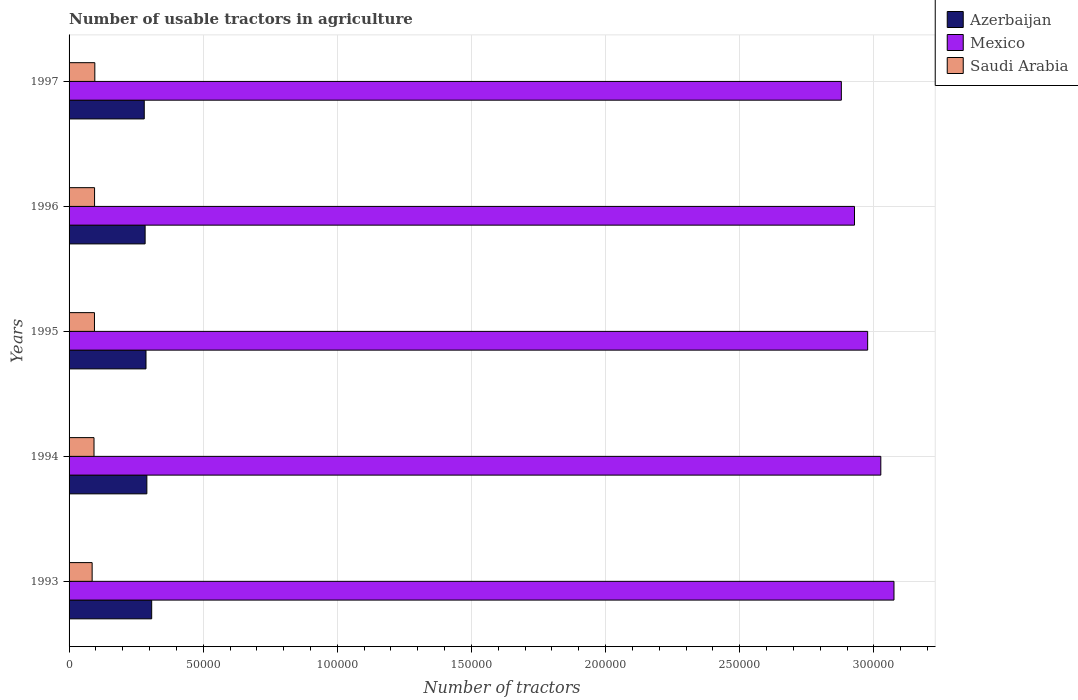How many groups of bars are there?
Give a very brief answer. 5. Are the number of bars on each tick of the Y-axis equal?
Offer a terse response. Yes. How many bars are there on the 4th tick from the bottom?
Keep it short and to the point. 3. What is the label of the 5th group of bars from the top?
Offer a terse response. 1993. What is the number of usable tractors in agriculture in Azerbaijan in 1997?
Your answer should be compact. 2.80e+04. Across all years, what is the maximum number of usable tractors in agriculture in Azerbaijan?
Your answer should be very brief. 3.08e+04. Across all years, what is the minimum number of usable tractors in agriculture in Saudi Arabia?
Offer a terse response. 8600. In which year was the number of usable tractors in agriculture in Mexico maximum?
Your response must be concise. 1993. In which year was the number of usable tractors in agriculture in Mexico minimum?
Your response must be concise. 1997. What is the total number of usable tractors in agriculture in Mexico in the graph?
Your response must be concise. 1.49e+06. What is the difference between the number of usable tractors in agriculture in Saudi Arabia in 1995 and that in 1996?
Your answer should be very brief. -31. What is the difference between the number of usable tractors in agriculture in Mexico in 1996 and the number of usable tractors in agriculture in Saudi Arabia in 1995?
Offer a very short reply. 2.83e+05. What is the average number of usable tractors in agriculture in Mexico per year?
Your answer should be very brief. 2.98e+05. In the year 1997, what is the difference between the number of usable tractors in agriculture in Saudi Arabia and number of usable tractors in agriculture in Azerbaijan?
Make the answer very short. -1.84e+04. In how many years, is the number of usable tractors in agriculture in Mexico greater than 160000 ?
Your answer should be compact. 5. What is the ratio of the number of usable tractors in agriculture in Azerbaijan in 1994 to that in 1996?
Ensure brevity in your answer.  1.02. Is the difference between the number of usable tractors in agriculture in Saudi Arabia in 1994 and 1996 greater than the difference between the number of usable tractors in agriculture in Azerbaijan in 1994 and 1996?
Offer a terse response. No. What is the difference between the highest and the lowest number of usable tractors in agriculture in Mexico?
Your answer should be very brief. 1.96e+04. Is the sum of the number of usable tractors in agriculture in Mexico in 1994 and 1997 greater than the maximum number of usable tractors in agriculture in Saudi Arabia across all years?
Offer a very short reply. Yes. What does the 1st bar from the top in 1996 represents?
Give a very brief answer. Saudi Arabia. What does the 1st bar from the bottom in 1997 represents?
Give a very brief answer. Azerbaijan. How many bars are there?
Offer a terse response. 15. Are all the bars in the graph horizontal?
Make the answer very short. Yes. How many years are there in the graph?
Keep it short and to the point. 5. Are the values on the major ticks of X-axis written in scientific E-notation?
Give a very brief answer. No. Does the graph contain grids?
Your response must be concise. Yes. Where does the legend appear in the graph?
Offer a very short reply. Top right. How many legend labels are there?
Offer a very short reply. 3. How are the legend labels stacked?
Provide a succinct answer. Vertical. What is the title of the graph?
Keep it short and to the point. Number of usable tractors in agriculture. What is the label or title of the X-axis?
Your answer should be compact. Number of tractors. What is the Number of tractors of Azerbaijan in 1993?
Provide a short and direct response. 3.08e+04. What is the Number of tractors of Mexico in 1993?
Keep it short and to the point. 3.08e+05. What is the Number of tractors of Saudi Arabia in 1993?
Your answer should be very brief. 8600. What is the Number of tractors in Azerbaijan in 1994?
Give a very brief answer. 2.90e+04. What is the Number of tractors of Mexico in 1994?
Your answer should be compact. 3.03e+05. What is the Number of tractors in Saudi Arabia in 1994?
Offer a terse response. 9300. What is the Number of tractors in Azerbaijan in 1995?
Offer a terse response. 2.87e+04. What is the Number of tractors of Mexico in 1995?
Provide a succinct answer. 2.98e+05. What is the Number of tractors in Saudi Arabia in 1995?
Provide a short and direct response. 9469. What is the Number of tractors of Azerbaijan in 1996?
Make the answer very short. 2.84e+04. What is the Number of tractors in Mexico in 1996?
Offer a terse response. 2.93e+05. What is the Number of tractors of Saudi Arabia in 1996?
Keep it short and to the point. 9500. What is the Number of tractors of Azerbaijan in 1997?
Provide a short and direct response. 2.80e+04. What is the Number of tractors of Mexico in 1997?
Make the answer very short. 2.88e+05. What is the Number of tractors in Saudi Arabia in 1997?
Provide a short and direct response. 9600. Across all years, what is the maximum Number of tractors of Azerbaijan?
Your answer should be compact. 3.08e+04. Across all years, what is the maximum Number of tractors in Mexico?
Provide a short and direct response. 3.08e+05. Across all years, what is the maximum Number of tractors of Saudi Arabia?
Your answer should be compact. 9600. Across all years, what is the minimum Number of tractors in Azerbaijan?
Ensure brevity in your answer.  2.80e+04. Across all years, what is the minimum Number of tractors of Mexico?
Make the answer very short. 2.88e+05. Across all years, what is the minimum Number of tractors in Saudi Arabia?
Give a very brief answer. 8600. What is the total Number of tractors of Azerbaijan in the graph?
Ensure brevity in your answer.  1.45e+05. What is the total Number of tractors of Mexico in the graph?
Provide a short and direct response. 1.49e+06. What is the total Number of tractors of Saudi Arabia in the graph?
Provide a short and direct response. 4.65e+04. What is the difference between the Number of tractors of Azerbaijan in 1993 and that in 1994?
Offer a terse response. 1800. What is the difference between the Number of tractors of Mexico in 1993 and that in 1994?
Keep it short and to the point. 4906. What is the difference between the Number of tractors in Saudi Arabia in 1993 and that in 1994?
Your answer should be very brief. -700. What is the difference between the Number of tractors in Azerbaijan in 1993 and that in 1995?
Offer a very short reply. 2125. What is the difference between the Number of tractors in Mexico in 1993 and that in 1995?
Provide a succinct answer. 9811. What is the difference between the Number of tractors in Saudi Arabia in 1993 and that in 1995?
Your answer should be very brief. -869. What is the difference between the Number of tractors of Azerbaijan in 1993 and that in 1996?
Your answer should be compact. 2449. What is the difference between the Number of tractors of Mexico in 1993 and that in 1996?
Provide a succinct answer. 1.47e+04. What is the difference between the Number of tractors of Saudi Arabia in 1993 and that in 1996?
Offer a terse response. -900. What is the difference between the Number of tractors of Azerbaijan in 1993 and that in 1997?
Offer a terse response. 2774. What is the difference between the Number of tractors in Mexico in 1993 and that in 1997?
Make the answer very short. 1.96e+04. What is the difference between the Number of tractors in Saudi Arabia in 1993 and that in 1997?
Provide a short and direct response. -1000. What is the difference between the Number of tractors in Azerbaijan in 1994 and that in 1995?
Provide a short and direct response. 325. What is the difference between the Number of tractors in Mexico in 1994 and that in 1995?
Your answer should be compact. 4905. What is the difference between the Number of tractors of Saudi Arabia in 1994 and that in 1995?
Keep it short and to the point. -169. What is the difference between the Number of tractors in Azerbaijan in 1994 and that in 1996?
Keep it short and to the point. 649. What is the difference between the Number of tractors of Mexico in 1994 and that in 1996?
Offer a very short reply. 9810. What is the difference between the Number of tractors of Saudi Arabia in 1994 and that in 1996?
Your answer should be compact. -200. What is the difference between the Number of tractors in Azerbaijan in 1994 and that in 1997?
Make the answer very short. 974. What is the difference between the Number of tractors of Mexico in 1994 and that in 1997?
Offer a very short reply. 1.47e+04. What is the difference between the Number of tractors of Saudi Arabia in 1994 and that in 1997?
Ensure brevity in your answer.  -300. What is the difference between the Number of tractors of Azerbaijan in 1995 and that in 1996?
Your response must be concise. 324. What is the difference between the Number of tractors in Mexico in 1995 and that in 1996?
Offer a terse response. 4905. What is the difference between the Number of tractors in Saudi Arabia in 1995 and that in 1996?
Your answer should be very brief. -31. What is the difference between the Number of tractors in Azerbaijan in 1995 and that in 1997?
Your answer should be very brief. 649. What is the difference between the Number of tractors of Mexico in 1995 and that in 1997?
Your response must be concise. 9810. What is the difference between the Number of tractors of Saudi Arabia in 1995 and that in 1997?
Ensure brevity in your answer.  -131. What is the difference between the Number of tractors of Azerbaijan in 1996 and that in 1997?
Provide a succinct answer. 325. What is the difference between the Number of tractors of Mexico in 1996 and that in 1997?
Give a very brief answer. 4905. What is the difference between the Number of tractors of Saudi Arabia in 1996 and that in 1997?
Provide a succinct answer. -100. What is the difference between the Number of tractors of Azerbaijan in 1993 and the Number of tractors of Mexico in 1994?
Provide a short and direct response. -2.72e+05. What is the difference between the Number of tractors of Azerbaijan in 1993 and the Number of tractors of Saudi Arabia in 1994?
Give a very brief answer. 2.15e+04. What is the difference between the Number of tractors in Mexico in 1993 and the Number of tractors in Saudi Arabia in 1994?
Your answer should be very brief. 2.98e+05. What is the difference between the Number of tractors in Azerbaijan in 1993 and the Number of tractors in Mexico in 1995?
Your answer should be very brief. -2.67e+05. What is the difference between the Number of tractors in Azerbaijan in 1993 and the Number of tractors in Saudi Arabia in 1995?
Your answer should be compact. 2.13e+04. What is the difference between the Number of tractors of Mexico in 1993 and the Number of tractors of Saudi Arabia in 1995?
Keep it short and to the point. 2.98e+05. What is the difference between the Number of tractors of Azerbaijan in 1993 and the Number of tractors of Mexico in 1996?
Provide a short and direct response. -2.62e+05. What is the difference between the Number of tractors in Azerbaijan in 1993 and the Number of tractors in Saudi Arabia in 1996?
Keep it short and to the point. 2.13e+04. What is the difference between the Number of tractors of Mexico in 1993 and the Number of tractors of Saudi Arabia in 1996?
Make the answer very short. 2.98e+05. What is the difference between the Number of tractors in Azerbaijan in 1993 and the Number of tractors in Mexico in 1997?
Your answer should be very brief. -2.57e+05. What is the difference between the Number of tractors of Azerbaijan in 1993 and the Number of tractors of Saudi Arabia in 1997?
Ensure brevity in your answer.  2.12e+04. What is the difference between the Number of tractors in Mexico in 1993 and the Number of tractors in Saudi Arabia in 1997?
Your answer should be compact. 2.98e+05. What is the difference between the Number of tractors of Azerbaijan in 1994 and the Number of tractors of Mexico in 1995?
Your answer should be very brief. -2.69e+05. What is the difference between the Number of tractors in Azerbaijan in 1994 and the Number of tractors in Saudi Arabia in 1995?
Your answer should be very brief. 1.95e+04. What is the difference between the Number of tractors of Mexico in 1994 and the Number of tractors of Saudi Arabia in 1995?
Your response must be concise. 2.93e+05. What is the difference between the Number of tractors of Azerbaijan in 1994 and the Number of tractors of Mexico in 1996?
Offer a terse response. -2.64e+05. What is the difference between the Number of tractors in Azerbaijan in 1994 and the Number of tractors in Saudi Arabia in 1996?
Ensure brevity in your answer.  1.95e+04. What is the difference between the Number of tractors of Mexico in 1994 and the Number of tractors of Saudi Arabia in 1996?
Provide a short and direct response. 2.93e+05. What is the difference between the Number of tractors of Azerbaijan in 1994 and the Number of tractors of Mexico in 1997?
Make the answer very short. -2.59e+05. What is the difference between the Number of tractors of Azerbaijan in 1994 and the Number of tractors of Saudi Arabia in 1997?
Your answer should be very brief. 1.94e+04. What is the difference between the Number of tractors of Mexico in 1994 and the Number of tractors of Saudi Arabia in 1997?
Your answer should be compact. 2.93e+05. What is the difference between the Number of tractors in Azerbaijan in 1995 and the Number of tractors in Mexico in 1996?
Your response must be concise. -2.64e+05. What is the difference between the Number of tractors of Azerbaijan in 1995 and the Number of tractors of Saudi Arabia in 1996?
Offer a terse response. 1.92e+04. What is the difference between the Number of tractors in Mexico in 1995 and the Number of tractors in Saudi Arabia in 1996?
Ensure brevity in your answer.  2.88e+05. What is the difference between the Number of tractors of Azerbaijan in 1995 and the Number of tractors of Mexico in 1997?
Offer a terse response. -2.59e+05. What is the difference between the Number of tractors in Azerbaijan in 1995 and the Number of tractors in Saudi Arabia in 1997?
Give a very brief answer. 1.91e+04. What is the difference between the Number of tractors in Mexico in 1995 and the Number of tractors in Saudi Arabia in 1997?
Your answer should be very brief. 2.88e+05. What is the difference between the Number of tractors in Azerbaijan in 1996 and the Number of tractors in Mexico in 1997?
Provide a succinct answer. -2.60e+05. What is the difference between the Number of tractors of Azerbaijan in 1996 and the Number of tractors of Saudi Arabia in 1997?
Give a very brief answer. 1.88e+04. What is the difference between the Number of tractors of Mexico in 1996 and the Number of tractors of Saudi Arabia in 1997?
Provide a succinct answer. 2.83e+05. What is the average Number of tractors in Azerbaijan per year?
Give a very brief answer. 2.90e+04. What is the average Number of tractors of Mexico per year?
Your response must be concise. 2.98e+05. What is the average Number of tractors in Saudi Arabia per year?
Offer a very short reply. 9293.8. In the year 1993, what is the difference between the Number of tractors in Azerbaijan and Number of tractors in Mexico?
Provide a short and direct response. -2.77e+05. In the year 1993, what is the difference between the Number of tractors of Azerbaijan and Number of tractors of Saudi Arabia?
Your answer should be compact. 2.22e+04. In the year 1993, what is the difference between the Number of tractors of Mexico and Number of tractors of Saudi Arabia?
Ensure brevity in your answer.  2.99e+05. In the year 1994, what is the difference between the Number of tractors of Azerbaijan and Number of tractors of Mexico?
Ensure brevity in your answer.  -2.74e+05. In the year 1994, what is the difference between the Number of tractors in Azerbaijan and Number of tractors in Saudi Arabia?
Provide a short and direct response. 1.97e+04. In the year 1994, what is the difference between the Number of tractors of Mexico and Number of tractors of Saudi Arabia?
Keep it short and to the point. 2.93e+05. In the year 1995, what is the difference between the Number of tractors in Azerbaijan and Number of tractors in Mexico?
Provide a short and direct response. -2.69e+05. In the year 1995, what is the difference between the Number of tractors in Azerbaijan and Number of tractors in Saudi Arabia?
Give a very brief answer. 1.92e+04. In the year 1995, what is the difference between the Number of tractors of Mexico and Number of tractors of Saudi Arabia?
Make the answer very short. 2.88e+05. In the year 1996, what is the difference between the Number of tractors in Azerbaijan and Number of tractors in Mexico?
Make the answer very short. -2.64e+05. In the year 1996, what is the difference between the Number of tractors of Azerbaijan and Number of tractors of Saudi Arabia?
Provide a succinct answer. 1.89e+04. In the year 1996, what is the difference between the Number of tractors in Mexico and Number of tractors in Saudi Arabia?
Give a very brief answer. 2.83e+05. In the year 1997, what is the difference between the Number of tractors in Azerbaijan and Number of tractors in Mexico?
Your answer should be compact. -2.60e+05. In the year 1997, what is the difference between the Number of tractors in Azerbaijan and Number of tractors in Saudi Arabia?
Offer a terse response. 1.84e+04. In the year 1997, what is the difference between the Number of tractors in Mexico and Number of tractors in Saudi Arabia?
Keep it short and to the point. 2.78e+05. What is the ratio of the Number of tractors in Azerbaijan in 1993 to that in 1994?
Make the answer very short. 1.06. What is the ratio of the Number of tractors of Mexico in 1993 to that in 1994?
Your answer should be very brief. 1.02. What is the ratio of the Number of tractors of Saudi Arabia in 1993 to that in 1994?
Ensure brevity in your answer.  0.92. What is the ratio of the Number of tractors of Azerbaijan in 1993 to that in 1995?
Keep it short and to the point. 1.07. What is the ratio of the Number of tractors in Mexico in 1993 to that in 1995?
Offer a very short reply. 1.03. What is the ratio of the Number of tractors of Saudi Arabia in 1993 to that in 1995?
Provide a succinct answer. 0.91. What is the ratio of the Number of tractors of Azerbaijan in 1993 to that in 1996?
Keep it short and to the point. 1.09. What is the ratio of the Number of tractors of Mexico in 1993 to that in 1996?
Give a very brief answer. 1.05. What is the ratio of the Number of tractors in Saudi Arabia in 1993 to that in 1996?
Offer a terse response. 0.91. What is the ratio of the Number of tractors of Azerbaijan in 1993 to that in 1997?
Your response must be concise. 1.1. What is the ratio of the Number of tractors of Mexico in 1993 to that in 1997?
Make the answer very short. 1.07. What is the ratio of the Number of tractors of Saudi Arabia in 1993 to that in 1997?
Your answer should be compact. 0.9. What is the ratio of the Number of tractors of Azerbaijan in 1994 to that in 1995?
Ensure brevity in your answer.  1.01. What is the ratio of the Number of tractors of Mexico in 1994 to that in 1995?
Your answer should be compact. 1.02. What is the ratio of the Number of tractors of Saudi Arabia in 1994 to that in 1995?
Your answer should be very brief. 0.98. What is the ratio of the Number of tractors in Azerbaijan in 1994 to that in 1996?
Provide a succinct answer. 1.02. What is the ratio of the Number of tractors in Mexico in 1994 to that in 1996?
Give a very brief answer. 1.03. What is the ratio of the Number of tractors of Saudi Arabia in 1994 to that in 1996?
Offer a terse response. 0.98. What is the ratio of the Number of tractors of Azerbaijan in 1994 to that in 1997?
Keep it short and to the point. 1.03. What is the ratio of the Number of tractors in Mexico in 1994 to that in 1997?
Give a very brief answer. 1.05. What is the ratio of the Number of tractors of Saudi Arabia in 1994 to that in 1997?
Your response must be concise. 0.97. What is the ratio of the Number of tractors in Azerbaijan in 1995 to that in 1996?
Give a very brief answer. 1.01. What is the ratio of the Number of tractors in Mexico in 1995 to that in 1996?
Your answer should be very brief. 1.02. What is the ratio of the Number of tractors in Azerbaijan in 1995 to that in 1997?
Your answer should be very brief. 1.02. What is the ratio of the Number of tractors in Mexico in 1995 to that in 1997?
Offer a very short reply. 1.03. What is the ratio of the Number of tractors in Saudi Arabia in 1995 to that in 1997?
Offer a very short reply. 0.99. What is the ratio of the Number of tractors of Azerbaijan in 1996 to that in 1997?
Your answer should be very brief. 1.01. What is the ratio of the Number of tractors of Mexico in 1996 to that in 1997?
Your answer should be very brief. 1.02. What is the difference between the highest and the second highest Number of tractors in Azerbaijan?
Give a very brief answer. 1800. What is the difference between the highest and the second highest Number of tractors in Mexico?
Give a very brief answer. 4906. What is the difference between the highest and the lowest Number of tractors in Azerbaijan?
Your answer should be compact. 2774. What is the difference between the highest and the lowest Number of tractors in Mexico?
Provide a succinct answer. 1.96e+04. 